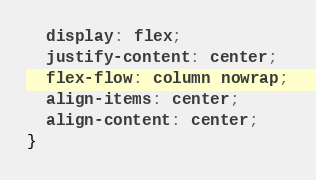<code> <loc_0><loc_0><loc_500><loc_500><_CSS_>  display: flex;
  justify-content: center;
  flex-flow: column nowrap;
  align-items: center;
  align-content: center;
}</code> 